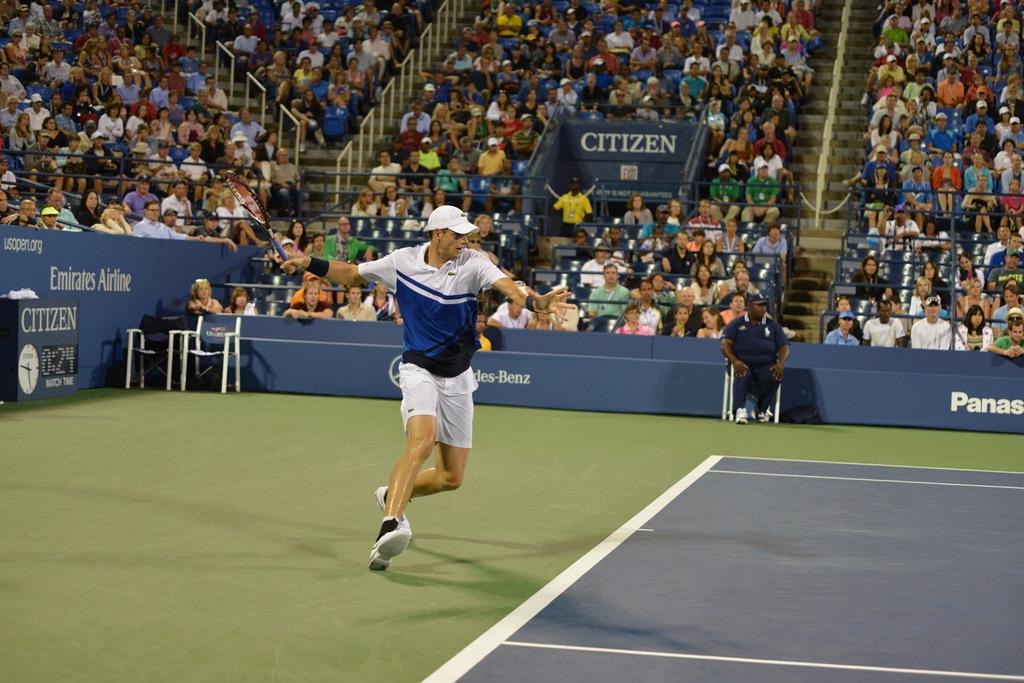Please provide a concise description of this image. This image is clicked in an auditorium, where there is badminton game going on. A person is playing badminton game. in this image he is holding racket with his hand. So many people they are sitting in auditorium and watching this match. A person in middle is sitting in chair. 